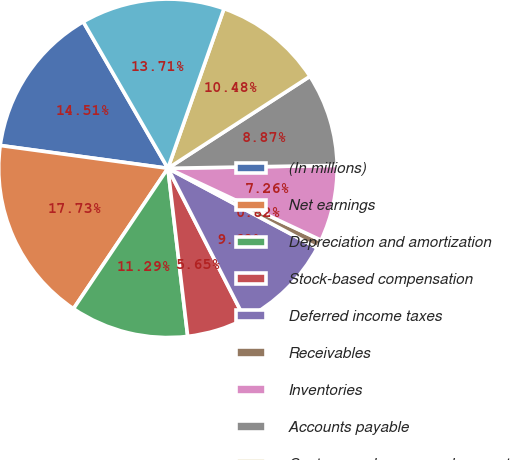<chart> <loc_0><loc_0><loc_500><loc_500><pie_chart><fcel>(In millions)<fcel>Net earnings<fcel>Depreciation and amortization<fcel>Stock-based compensation<fcel>Deferred income taxes<fcel>Receivables<fcel>Inventories<fcel>Accounts payable<fcel>Customer advances and amounts<fcel>Postretirement benefit plans<nl><fcel>14.51%<fcel>17.73%<fcel>11.29%<fcel>5.65%<fcel>9.68%<fcel>0.82%<fcel>7.26%<fcel>8.87%<fcel>10.48%<fcel>13.71%<nl></chart> 